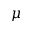Convert formula to latex. <formula><loc_0><loc_0><loc_500><loc_500>\mu</formula> 